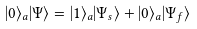Convert formula to latex. <formula><loc_0><loc_0><loc_500><loc_500>| 0 \rangle _ { a } | \Psi \rangle = | 1 \rangle _ { a } | \Psi _ { s } \rangle + | 0 \rangle _ { a } | \Psi _ { f } \rangle</formula> 